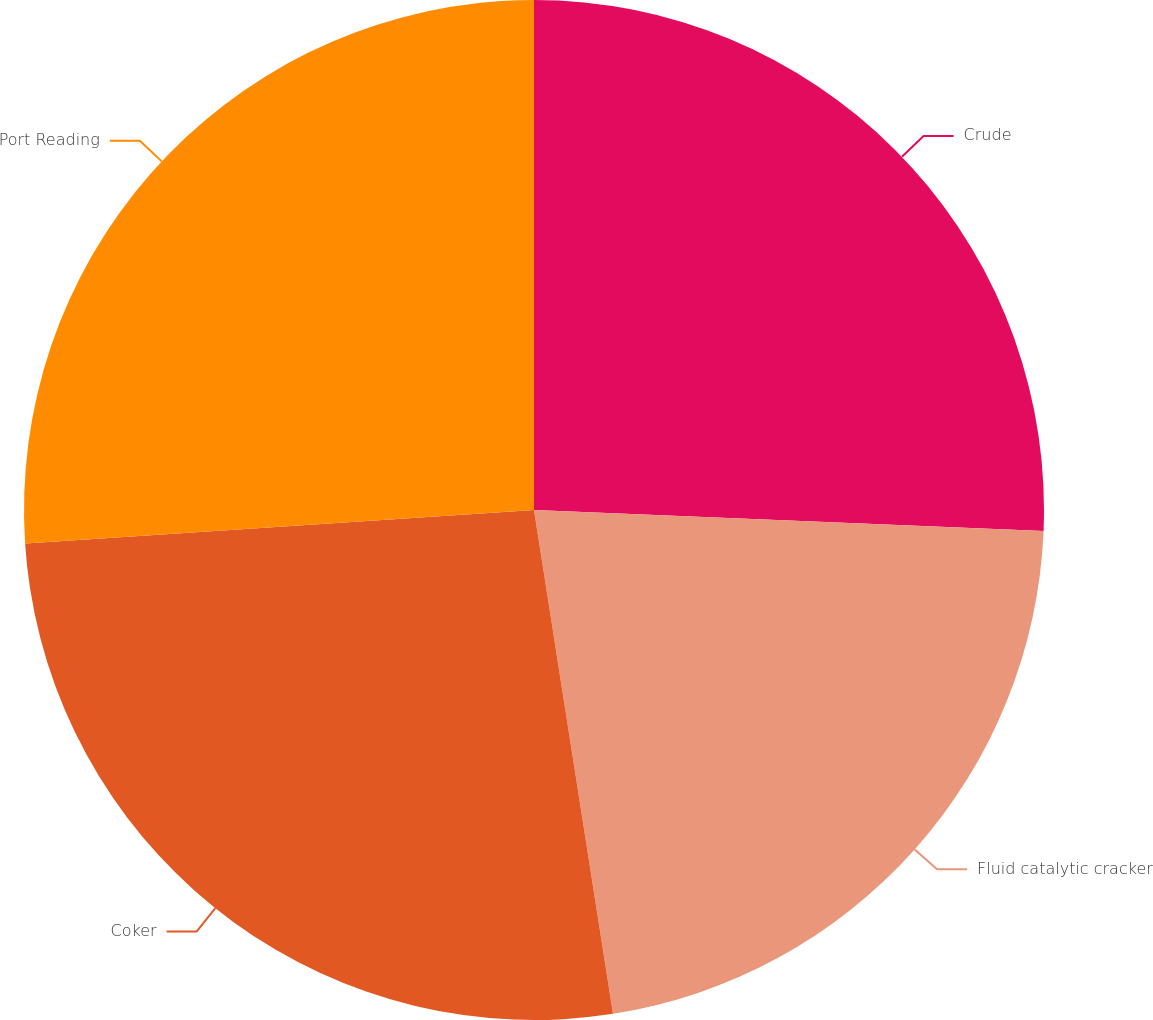<chart> <loc_0><loc_0><loc_500><loc_500><pie_chart><fcel>Crude<fcel>Fluid catalytic cracker<fcel>Coker<fcel>Port Reading<nl><fcel>25.65%<fcel>21.87%<fcel>26.43%<fcel>26.04%<nl></chart> 